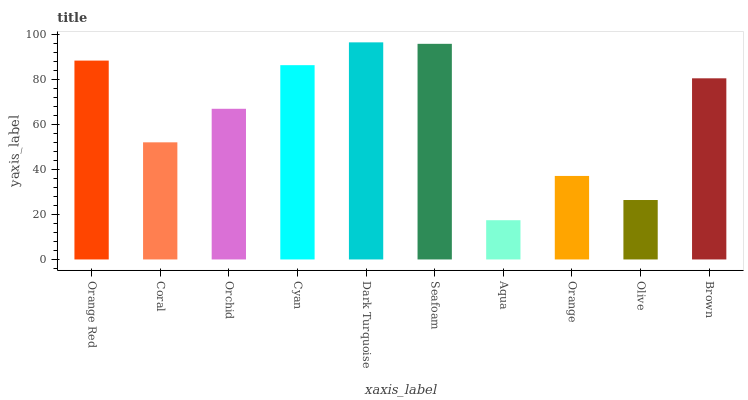Is Aqua the minimum?
Answer yes or no. Yes. Is Dark Turquoise the maximum?
Answer yes or no. Yes. Is Coral the minimum?
Answer yes or no. No. Is Coral the maximum?
Answer yes or no. No. Is Orange Red greater than Coral?
Answer yes or no. Yes. Is Coral less than Orange Red?
Answer yes or no. Yes. Is Coral greater than Orange Red?
Answer yes or no. No. Is Orange Red less than Coral?
Answer yes or no. No. Is Brown the high median?
Answer yes or no. Yes. Is Orchid the low median?
Answer yes or no. Yes. Is Aqua the high median?
Answer yes or no. No. Is Aqua the low median?
Answer yes or no. No. 